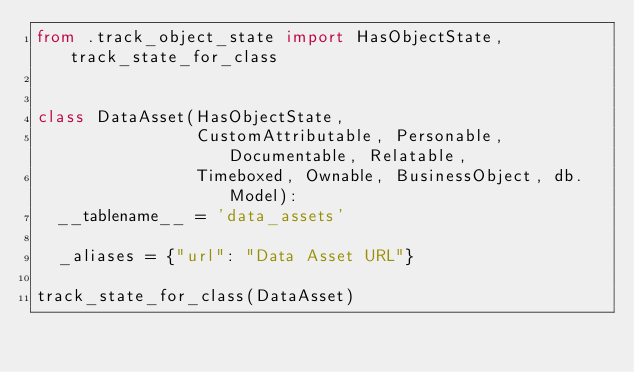Convert code to text. <code><loc_0><loc_0><loc_500><loc_500><_Python_>from .track_object_state import HasObjectState, track_state_for_class


class DataAsset(HasObjectState,
                CustomAttributable, Personable, Documentable, Relatable,
                Timeboxed, Ownable, BusinessObject, db.Model):
  __tablename__ = 'data_assets'

  _aliases = {"url": "Data Asset URL"}

track_state_for_class(DataAsset)
</code> 